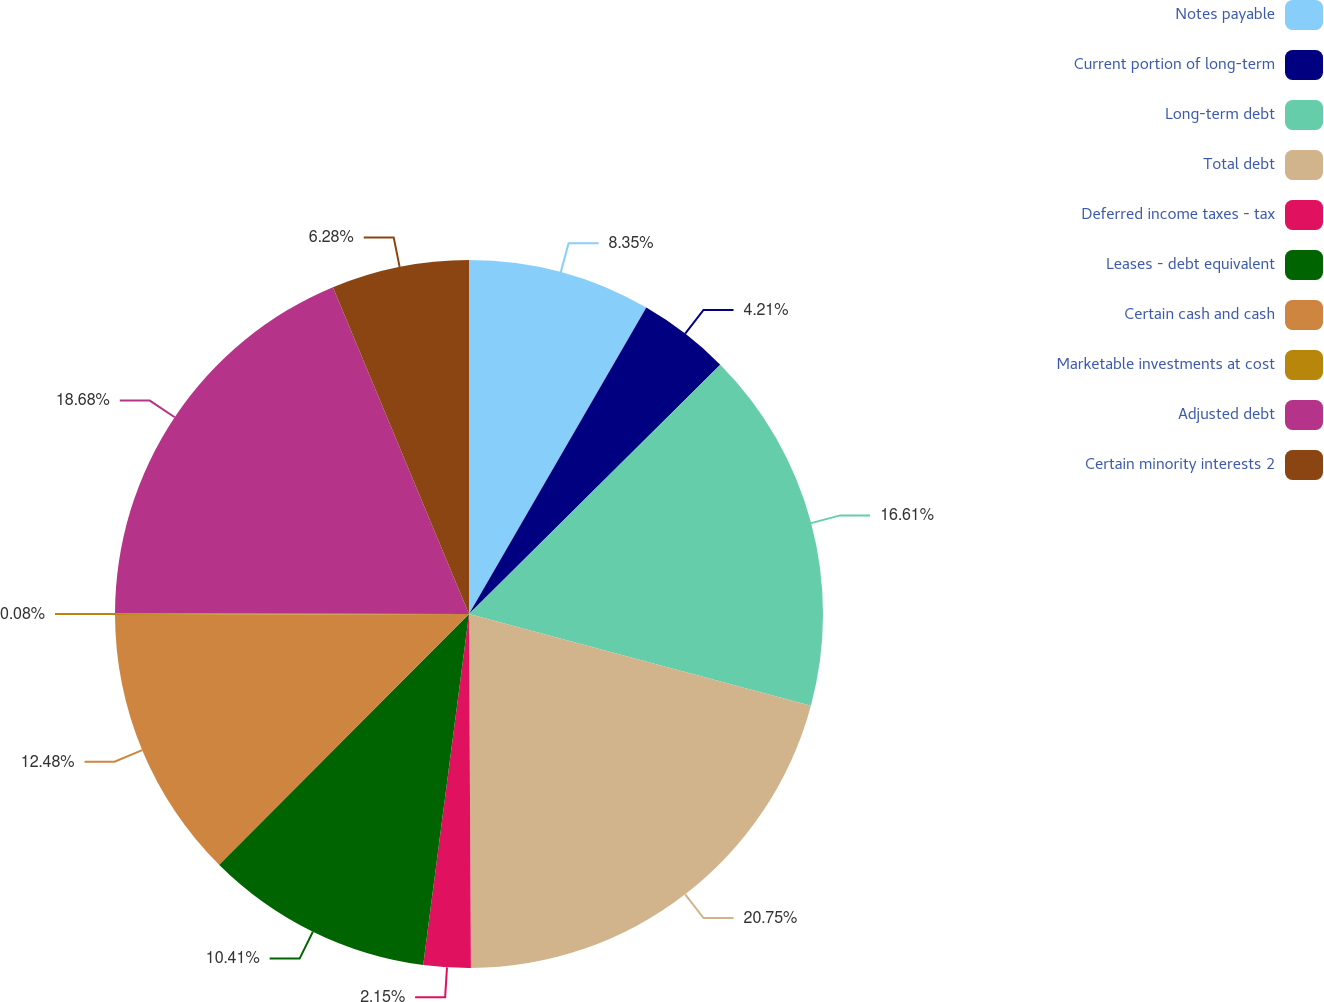<chart> <loc_0><loc_0><loc_500><loc_500><pie_chart><fcel>Notes payable<fcel>Current portion of long-term<fcel>Long-term debt<fcel>Total debt<fcel>Deferred income taxes - tax<fcel>Leases - debt equivalent<fcel>Certain cash and cash<fcel>Marketable investments at cost<fcel>Adjusted debt<fcel>Certain minority interests 2<nl><fcel>8.35%<fcel>4.21%<fcel>16.61%<fcel>20.74%<fcel>2.15%<fcel>10.41%<fcel>12.48%<fcel>0.08%<fcel>18.68%<fcel>6.28%<nl></chart> 